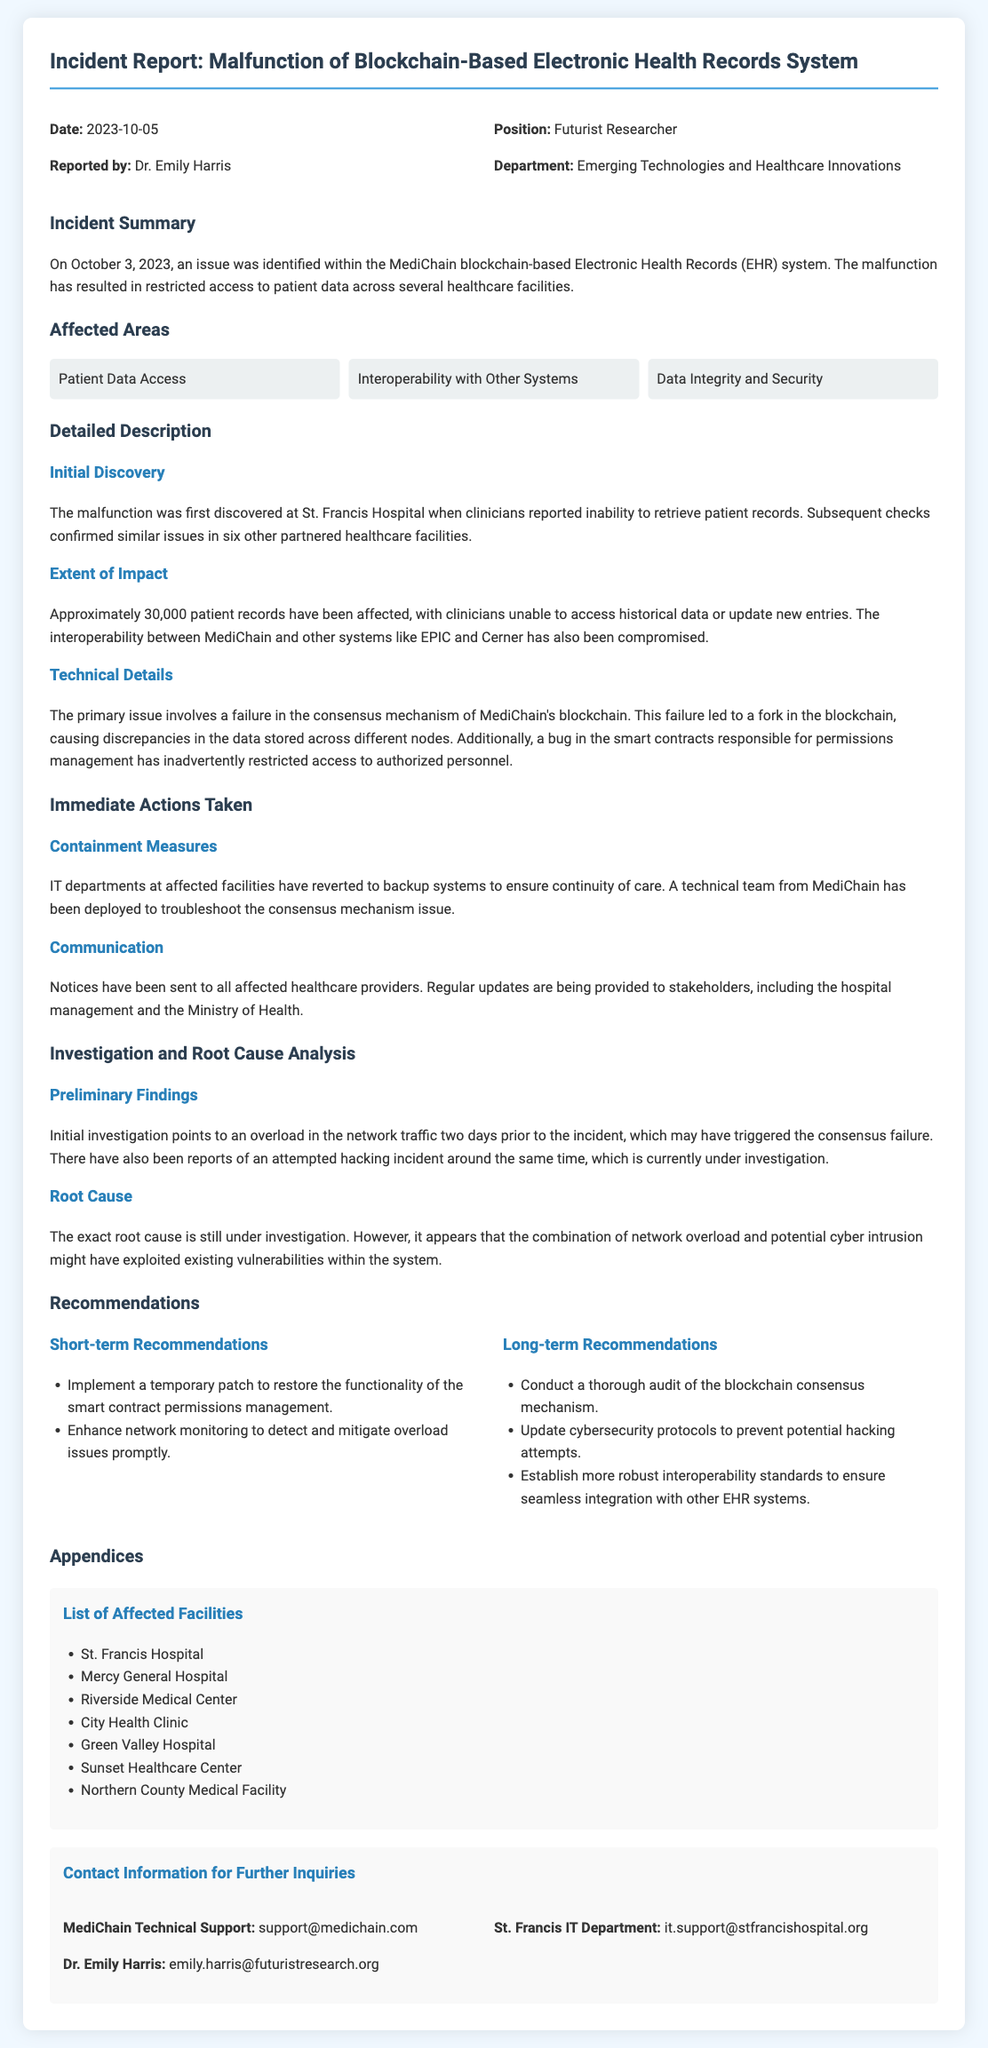What is the date of the incident? The date of the incident is specified at the beginning of the report as October 3, 2023.
Answer: October 3, 2023 Who reported the incident? The report indicates that it was reported by Dr. Emily Harris.
Answer: Dr. Emily Harris What are the affected areas listed in the report? The report specifies that the affected areas include Patient Data Access, Interoperability with Other Systems, and Data Integrity and Security.
Answer: Patient Data Access, Interoperability with Other Systems, Data Integrity and Security How many patient records were affected? The report mentions that approximately 30,000 patient records have been affected.
Answer: 30,000 What is the primary issue identified in the technical details? The primary issue identified involves a failure in the consensus mechanism of MediChain's blockchain.
Answer: Failure in the consensus mechanism What are the short-term recommendations provided? The report lists short-term recommendations that include implementing a temporary patch and enhancing network monitoring.
Answer: Implement a temporary patch, enhance network monitoring Which facility first discovered the malfunction? The malfunction was first discovered at St. Francis Hospital.
Answer: St. Francis Hospital What triggered the consensus failure according to preliminary findings? The preliminary findings suggest that an overload in the network traffic triggered the consensus failure.
Answer: Overload in network traffic Who can be contacted for further inquiries? The report provides contact information, including MediChain Technical Support and Dr. Emily Harris, for further inquiries.
Answer: MediChain Technical Support, Dr. Emily Harris 